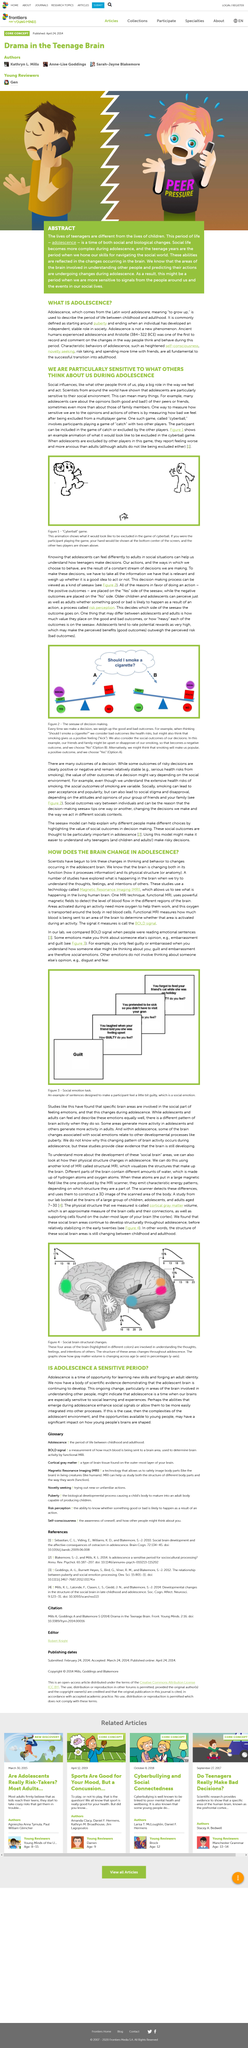Identify some key points in this picture. During a decision-making process, adolescents and adults may differ in their approach to evaluating the value of positive and negative outcomes. While adolescents may place greater importance on positive outcomes, adults may place greater emphasis on the potential consequences of the decision. The social brain area of the brain is associated with social emotions. Figure 1 depicts a body part that is typically displayed at the bottom of the image. This body part is the hand. Magnetic Resonance Imaging, commonly abbreviated as MRI, is a medical imaging technique that uses strong magnetic fields and radio waves to produce detailed images of the body's internal structures. MRI is often used to diagnose and monitor a wide range of medical conditions, including injuries, diseases of the brain and nervous system, and certain types of cancer. Unlike other imaging techniques such as CT scans or X-rays, MRI does not use ionizing radiation and is therefore considered to be a safe and non-invasive option for medical imaging. The highlighted areas in the photo are involved with understanding the thoughts, feelings, and intentions of others. 